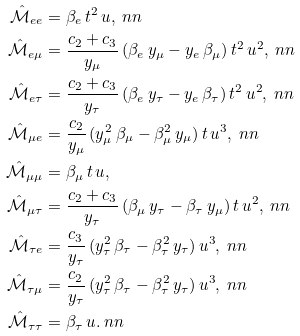Convert formula to latex. <formula><loc_0><loc_0><loc_500><loc_500>\mathcal { \hat { M } } _ { e e } & = \beta _ { e } \, t ^ { 2 } \, u , \ n n \\ \mathcal { \hat { M } } _ { e \mu } & = \frac { c _ { 2 } + c _ { 3 } } { y _ { \mu } } \, ( \beta _ { e } \, y _ { \mu } - y _ { e } \, \beta _ { \mu } ) \, t ^ { 2 } \, u ^ { 2 } , \ n n \\ \mathcal { \hat { M } } _ { e \tau } & = \frac { c _ { 2 } + c _ { 3 } } { y _ { \tau } } \, ( \beta _ { e } \, y _ { \tau } - y _ { e } \, \beta _ { \tau } ) \, t ^ { 2 } \, u ^ { 2 } , \ n n \\ \mathcal { \hat { M } } _ { \mu e } & = \frac { c _ { 2 } } { y _ { \mu } } \, ( y _ { \mu } ^ { 2 } \, \beta _ { \mu } - \beta _ { \mu } ^ { 2 } \, y _ { \mu } ) \, t \, u ^ { 3 } , \ n n \\ \mathcal { \hat { M } } _ { \mu \mu } & = \beta _ { \mu } \, t \, u , \\ \mathcal { \hat { M } } _ { \mu \tau } & = \frac { c _ { 2 } + c _ { 3 } } { y _ { \tau } } \, ( \beta _ { \mu } \, y _ { \tau } - \beta _ { \tau } \, y _ { \mu } ) \, t \, u ^ { 2 } , \ n n \\ \mathcal { \hat { M } } _ { \tau e } & = \frac { c _ { 3 } } { y _ { \tau } } \, ( y ^ { 2 } _ { \tau } \, \beta _ { \tau } - \beta _ { \tau } ^ { 2 } \, y _ { \tau } ) \, u ^ { 3 } , \ n n \\ \mathcal { \hat { M } } _ { \tau \mu } & = \frac { c _ { 2 } } { y _ { \tau } } \, ( y _ { \tau } ^ { 2 } \, \beta _ { \tau } - \beta _ { \tau } ^ { 2 } \, y _ { \tau } ) \, u ^ { 3 } , \ n n \\ \mathcal { \hat { M } } _ { \tau \tau } & = \beta _ { \tau } \, u . \ n n</formula> 